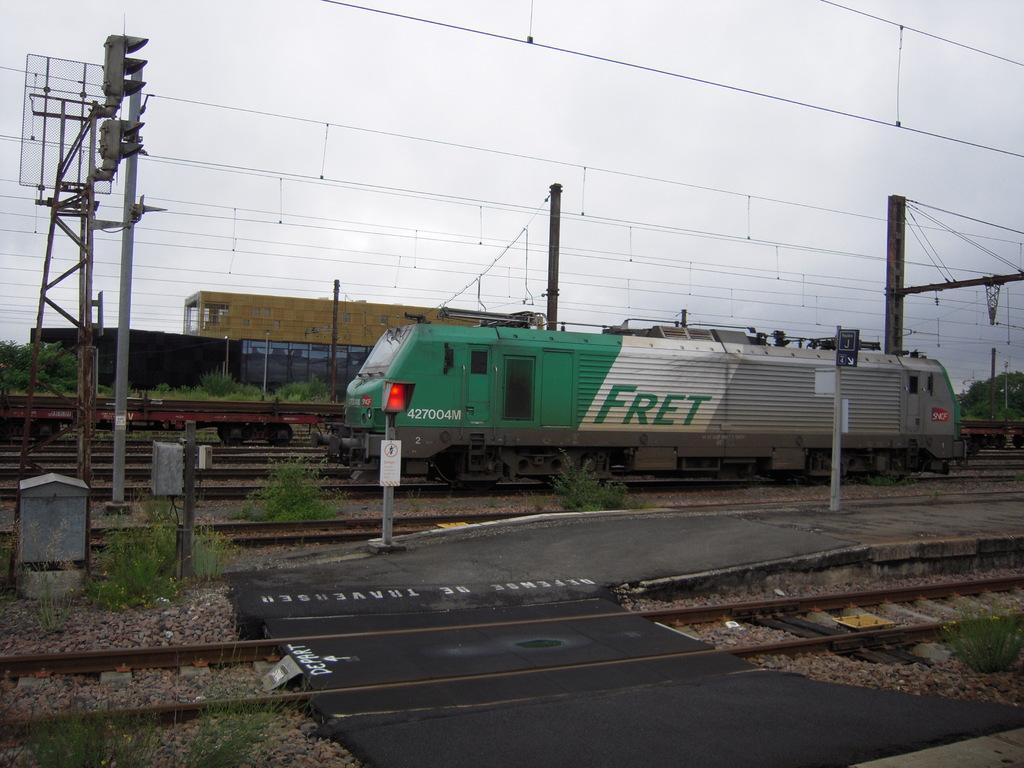<image>
Render a clear and concise summary of the photo. Green, white , and gray train which says the word FRET on it. 